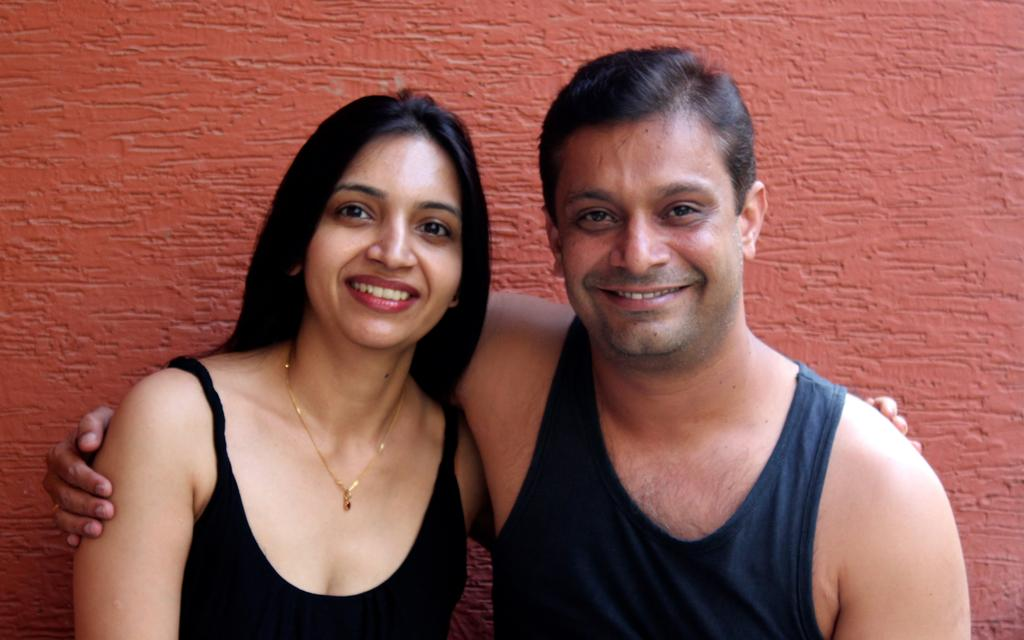How many people are in the image? There are persons in the image, but the exact number is not specified. What is the background of the image? The persons are in front of a wall. What type of guitar is being played by the person in the image? There is no guitar present in the image. What is the tendency of the persons in the image to make payments? There is no information about payments or tendencies in the image. 